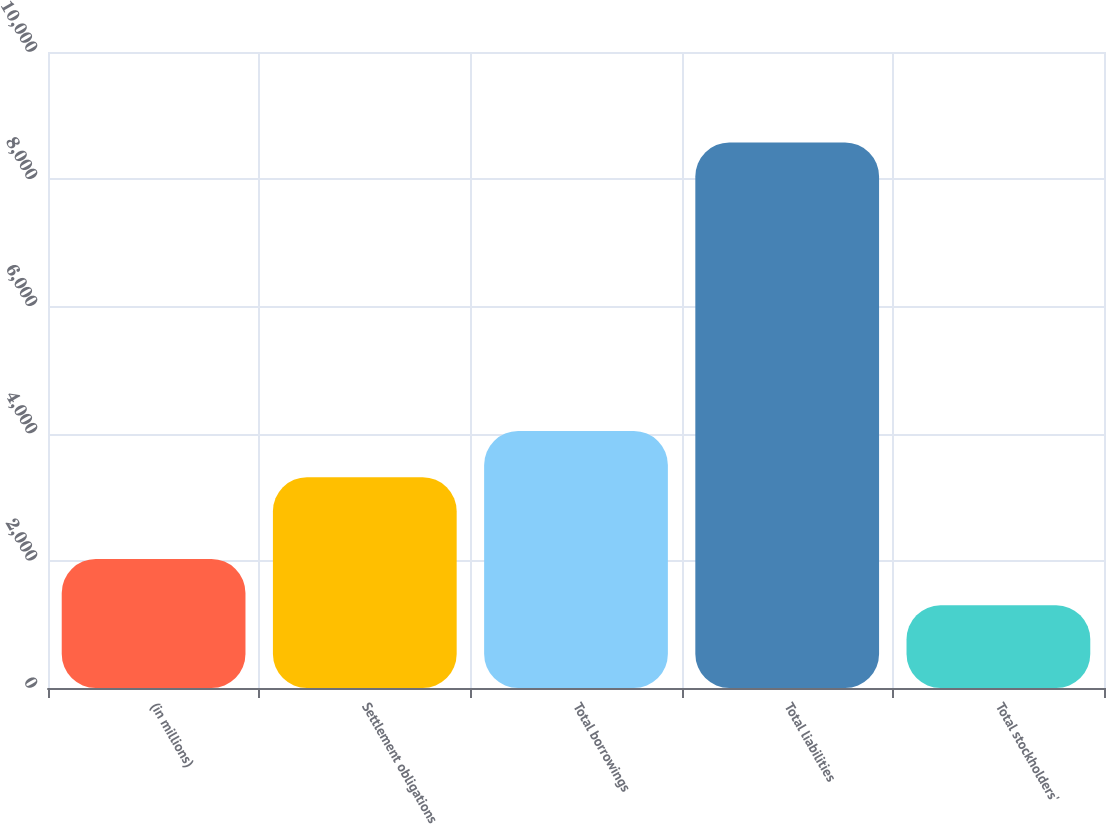Convert chart. <chart><loc_0><loc_0><loc_500><loc_500><bar_chart><fcel>(in millions)<fcel>Settlement obligations<fcel>Total borrowings<fcel>Total liabilities<fcel>Total stockholders'<nl><fcel>2028.07<fcel>3313.7<fcel>4041.37<fcel>8577.1<fcel>1300.4<nl></chart> 